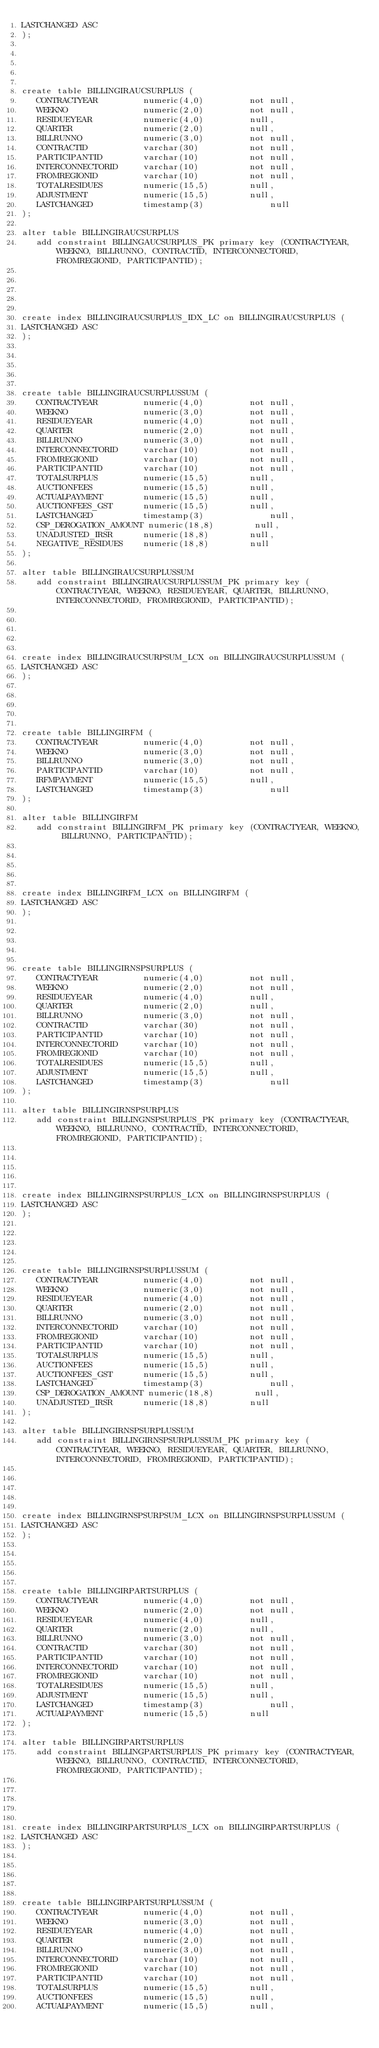<code> <loc_0><loc_0><loc_500><loc_500><_SQL_>LASTCHANGED ASC
);





create table BILLINGIRAUCSURPLUS (
   CONTRACTYEAR         numeric(4,0)         not null,
   WEEKNO               numeric(2,0)         not null,
   RESIDUEYEAR          numeric(4,0)         null,
   QUARTER              numeric(2,0)         null,
   BILLRUNNO            numeric(3,0)         not null,
   CONTRACTID           varchar(30)          not null,
   PARTICIPANTID        varchar(10)          not null,
   INTERCONNECTORID     varchar(10)          not null,
   FROMREGIONID         varchar(10)          not null,
   TOTALRESIDUES        numeric(15,5)        null,
   ADJUSTMENT           numeric(15,5)        null,
   LASTCHANGED          timestamp(3)             null
);

alter table BILLINGIRAUCSURPLUS
   add constraint BILLINGAUCSURPLUS_PK primary key (CONTRACTYEAR, WEEKNO, BILLRUNNO, CONTRACTID, INTERCONNECTORID, FROMREGIONID, PARTICIPANTID);





create index BILLINGIRAUCSURPLUS_IDX_LC on BILLINGIRAUCSURPLUS (
LASTCHANGED ASC
);





create table BILLINGIRAUCSURPLUSSUM (
   CONTRACTYEAR         numeric(4,0)         not null,
   WEEKNO               numeric(3,0)         not null,
   RESIDUEYEAR          numeric(4,0)         not null,
   QUARTER              numeric(2,0)         not null,
   BILLRUNNO            numeric(3,0)         not null,
   INTERCONNECTORID     varchar(10)          not null,
   FROMREGIONID         varchar(10)          not null,
   PARTICIPANTID        varchar(10)          not null,
   TOTALSURPLUS         numeric(15,5)        null,
   AUCTIONFEES          numeric(15,5)        null,
   ACTUALPAYMENT        numeric(15,5)        null,
   AUCTIONFEES_GST      numeric(15,5)        null,
   LASTCHANGED          timestamp(3)             null,
   CSP_DEROGATION_AMOUNT numeric(18,8)        null,
   UNADJUSTED_IRSR      numeric(18,8)        null,
   NEGATIVE_RESIDUES    numeric(18,8)        null
);

alter table BILLINGIRAUCSURPLUSSUM
   add constraint BILLINGIRAUCSURPLUSSUM_PK primary key (CONTRACTYEAR, WEEKNO, RESIDUEYEAR, QUARTER, BILLRUNNO, INTERCONNECTORID, FROMREGIONID, PARTICIPANTID);





create index BILLINGIRAUCSURPSUM_LCX on BILLINGIRAUCSURPLUSSUM (
LASTCHANGED ASC
);





create table BILLINGIRFM (
   CONTRACTYEAR         numeric(4,0)         not null,
   WEEKNO               numeric(3,0)         not null,
   BILLRUNNO            numeric(3,0)         not null,
   PARTICIPANTID        varchar(10)          not null,
   IRFMPAYMENT          numeric(15,5)        null,
   LASTCHANGED          timestamp(3)             null
);

alter table BILLINGIRFM
   add constraint BILLINGIRFM_PK primary key (CONTRACTYEAR, WEEKNO, BILLRUNNO, PARTICIPANTID);





create index BILLINGIRFM_LCX on BILLINGIRFM (
LASTCHANGED ASC
);





create table BILLINGIRNSPSURPLUS (
   CONTRACTYEAR         numeric(4,0)         not null,
   WEEKNO               numeric(2,0)         not null,
   RESIDUEYEAR          numeric(4,0)         null,
   QUARTER              numeric(2,0)         null,
   BILLRUNNO            numeric(3,0)         not null,
   CONTRACTID           varchar(30)          not null,
   PARTICIPANTID        varchar(10)          not null,
   INTERCONNECTORID     varchar(10)          not null,
   FROMREGIONID         varchar(10)          not null,
   TOTALRESIDUES        numeric(15,5)        null,
   ADJUSTMENT           numeric(15,5)        null,
   LASTCHANGED          timestamp(3)             null
);

alter table BILLINGIRNSPSURPLUS
   add constraint BILLINGNSPSURPLUS_PK primary key (CONTRACTYEAR, WEEKNO, BILLRUNNO, CONTRACTID, INTERCONNECTORID, FROMREGIONID, PARTICIPANTID);





create index BILLINGIRNSPSURPLUS_LCX on BILLINGIRNSPSURPLUS (
LASTCHANGED ASC
);





create table BILLINGIRNSPSURPLUSSUM (
   CONTRACTYEAR         numeric(4,0)         not null,
   WEEKNO               numeric(3,0)         not null,
   RESIDUEYEAR          numeric(4,0)         not null,
   QUARTER              numeric(2,0)         not null,
   BILLRUNNO            numeric(3,0)         not null,
   INTERCONNECTORID     varchar(10)          not null,
   FROMREGIONID         varchar(10)          not null,
   PARTICIPANTID        varchar(10)          not null,
   TOTALSURPLUS         numeric(15,5)        null,
   AUCTIONFEES          numeric(15,5)        null,
   AUCTIONFEES_GST      numeric(15,5)        null,
   LASTCHANGED          timestamp(3)             null,
   CSP_DEROGATION_AMOUNT numeric(18,8)        null,
   UNADJUSTED_IRSR      numeric(18,8)        null
);

alter table BILLINGIRNSPSURPLUSSUM
   add constraint BILLINGIRNSPSURPLUSSUM_PK primary key (CONTRACTYEAR, WEEKNO, RESIDUEYEAR, QUARTER, BILLRUNNO, INTERCONNECTORID, FROMREGIONID, PARTICIPANTID);





create index BILLINGIRNSPSURPSUM_LCX on BILLINGIRNSPSURPLUSSUM (
LASTCHANGED ASC
);





create table BILLINGIRPARTSURPLUS (
   CONTRACTYEAR         numeric(4,0)         not null,
   WEEKNO               numeric(2,0)         not null,
   RESIDUEYEAR          numeric(4,0)         null,
   QUARTER              numeric(2,0)         null,
   BILLRUNNO            numeric(3,0)         not null,
   CONTRACTID           varchar(30)          not null,
   PARTICIPANTID        varchar(10)          not null,
   INTERCONNECTORID     varchar(10)          not null,
   FROMREGIONID         varchar(10)          not null,
   TOTALRESIDUES        numeric(15,5)        null,
   ADJUSTMENT           numeric(15,5)        null,
   LASTCHANGED          timestamp(3)             null,
   ACTUALPAYMENT        numeric(15,5)        null
);

alter table BILLINGIRPARTSURPLUS
   add constraint BILLINGPARTSURPLUS_PK primary key (CONTRACTYEAR, WEEKNO, BILLRUNNO, CONTRACTID, INTERCONNECTORID, FROMREGIONID, PARTICIPANTID);





create index BILLINGIRPARTSURPLUS_LCX on BILLINGIRPARTSURPLUS (
LASTCHANGED ASC
);





create table BILLINGIRPARTSURPLUSSUM (
   CONTRACTYEAR         numeric(4,0)         not null,
   WEEKNO               numeric(3,0)         not null,
   RESIDUEYEAR          numeric(4,0)         not null,
   QUARTER              numeric(2,0)         not null,
   BILLRUNNO            numeric(3,0)         not null,
   INTERCONNECTORID     varchar(10)          not null,
   FROMREGIONID         varchar(10)          not null,
   PARTICIPANTID        varchar(10)          not null,
   TOTALSURPLUS         numeric(15,5)        null,
   AUCTIONFEES          numeric(15,5)        null,
   ACTUALPAYMENT        numeric(15,5)        null,</code> 